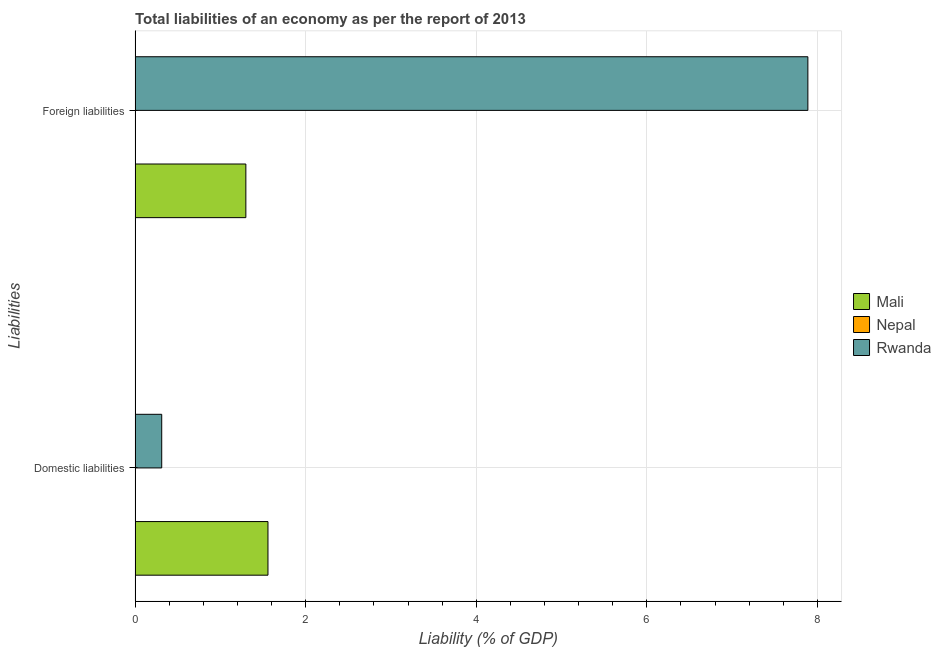Are the number of bars per tick equal to the number of legend labels?
Offer a very short reply. No. How many bars are there on the 1st tick from the top?
Your answer should be very brief. 2. How many bars are there on the 1st tick from the bottom?
Keep it short and to the point. 2. What is the label of the 2nd group of bars from the top?
Provide a succinct answer. Domestic liabilities. Across all countries, what is the maximum incurrence of foreign liabilities?
Make the answer very short. 7.89. In which country was the incurrence of domestic liabilities maximum?
Give a very brief answer. Mali. What is the total incurrence of domestic liabilities in the graph?
Make the answer very short. 1.87. What is the difference between the incurrence of foreign liabilities in Rwanda and that in Mali?
Give a very brief answer. 6.59. What is the difference between the incurrence of foreign liabilities in Rwanda and the incurrence of domestic liabilities in Nepal?
Make the answer very short. 7.89. What is the average incurrence of foreign liabilities per country?
Provide a succinct answer. 3.06. What is the difference between the incurrence of foreign liabilities and incurrence of domestic liabilities in Rwanda?
Your answer should be very brief. 7.58. In how many countries, is the incurrence of foreign liabilities greater than 2.8 %?
Keep it short and to the point. 1. What is the ratio of the incurrence of domestic liabilities in Rwanda to that in Mali?
Your answer should be compact. 0.2. In how many countries, is the incurrence of domestic liabilities greater than the average incurrence of domestic liabilities taken over all countries?
Keep it short and to the point. 1. How many bars are there?
Your answer should be very brief. 4. Are all the bars in the graph horizontal?
Provide a succinct answer. Yes. How many countries are there in the graph?
Keep it short and to the point. 3. Are the values on the major ticks of X-axis written in scientific E-notation?
Your answer should be compact. No. Does the graph contain any zero values?
Offer a terse response. Yes. Does the graph contain grids?
Offer a very short reply. Yes. Where does the legend appear in the graph?
Your answer should be compact. Center right. How many legend labels are there?
Provide a succinct answer. 3. What is the title of the graph?
Provide a succinct answer. Total liabilities of an economy as per the report of 2013. What is the label or title of the X-axis?
Ensure brevity in your answer.  Liability (% of GDP). What is the label or title of the Y-axis?
Your answer should be compact. Liabilities. What is the Liability (% of GDP) of Mali in Domestic liabilities?
Offer a terse response. 1.56. What is the Liability (% of GDP) in Rwanda in Domestic liabilities?
Ensure brevity in your answer.  0.31. What is the Liability (% of GDP) in Mali in Foreign liabilities?
Ensure brevity in your answer.  1.3. What is the Liability (% of GDP) in Nepal in Foreign liabilities?
Provide a short and direct response. 0. What is the Liability (% of GDP) in Rwanda in Foreign liabilities?
Your response must be concise. 7.89. Across all Liabilities, what is the maximum Liability (% of GDP) in Mali?
Ensure brevity in your answer.  1.56. Across all Liabilities, what is the maximum Liability (% of GDP) in Rwanda?
Provide a short and direct response. 7.89. Across all Liabilities, what is the minimum Liability (% of GDP) in Mali?
Make the answer very short. 1.3. Across all Liabilities, what is the minimum Liability (% of GDP) of Rwanda?
Your answer should be compact. 0.31. What is the total Liability (% of GDP) of Mali in the graph?
Your answer should be compact. 2.86. What is the total Liability (% of GDP) in Nepal in the graph?
Keep it short and to the point. 0. What is the total Liability (% of GDP) in Rwanda in the graph?
Offer a very short reply. 8.2. What is the difference between the Liability (% of GDP) in Mali in Domestic liabilities and that in Foreign liabilities?
Offer a terse response. 0.26. What is the difference between the Liability (% of GDP) in Rwanda in Domestic liabilities and that in Foreign liabilities?
Your answer should be very brief. -7.58. What is the difference between the Liability (% of GDP) of Mali in Domestic liabilities and the Liability (% of GDP) of Rwanda in Foreign liabilities?
Provide a short and direct response. -6.33. What is the average Liability (% of GDP) of Mali per Liabilities?
Give a very brief answer. 1.43. What is the average Liability (% of GDP) in Rwanda per Liabilities?
Your answer should be very brief. 4.1. What is the difference between the Liability (% of GDP) of Mali and Liability (% of GDP) of Rwanda in Domestic liabilities?
Your response must be concise. 1.25. What is the difference between the Liability (% of GDP) in Mali and Liability (% of GDP) in Rwanda in Foreign liabilities?
Provide a short and direct response. -6.59. What is the ratio of the Liability (% of GDP) in Mali in Domestic liabilities to that in Foreign liabilities?
Keep it short and to the point. 1.2. What is the ratio of the Liability (% of GDP) of Rwanda in Domestic liabilities to that in Foreign liabilities?
Your response must be concise. 0.04. What is the difference between the highest and the second highest Liability (% of GDP) of Mali?
Your answer should be compact. 0.26. What is the difference between the highest and the second highest Liability (% of GDP) in Rwanda?
Offer a very short reply. 7.58. What is the difference between the highest and the lowest Liability (% of GDP) of Mali?
Provide a succinct answer. 0.26. What is the difference between the highest and the lowest Liability (% of GDP) of Rwanda?
Offer a terse response. 7.58. 